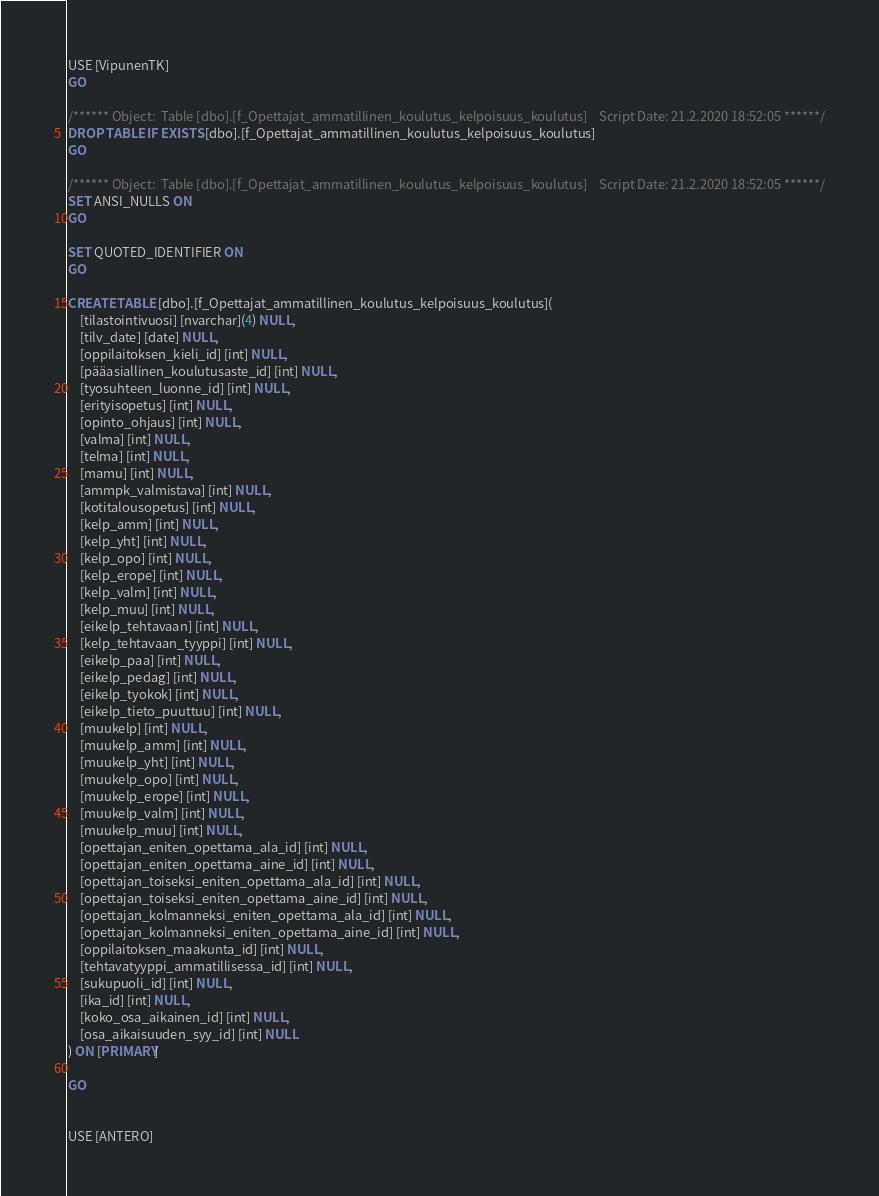Convert code to text. <code><loc_0><loc_0><loc_500><loc_500><_SQL_>USE [VipunenTK]
GO

/****** Object:  Table [dbo].[f_Opettajat_ammatillinen_koulutus_kelpoisuus_koulutus]    Script Date: 21.2.2020 18:52:05 ******/
DROP TABLE IF EXISTS [dbo].[f_Opettajat_ammatillinen_koulutus_kelpoisuus_koulutus]
GO

/****** Object:  Table [dbo].[f_Opettajat_ammatillinen_koulutus_kelpoisuus_koulutus]    Script Date: 21.2.2020 18:52:05 ******/
SET ANSI_NULLS ON
GO

SET QUOTED_IDENTIFIER ON
GO

CREATE TABLE [dbo].[f_Opettajat_ammatillinen_koulutus_kelpoisuus_koulutus](
	[tilastointivuosi] [nvarchar](4) NULL,
	[tilv_date] [date] NULL,
	[oppilaitoksen_kieli_id] [int] NULL,
	[pääasiallinen_koulutusaste_id] [int] NULL,
	[tyosuhteen_luonne_id] [int] NULL,
	[erityisopetus] [int] NULL,
	[opinto_ohjaus] [int] NULL,
	[valma] [int] NULL,
	[telma] [int] NULL,
	[mamu] [int] NULL,
	[ammpk_valmistava] [int] NULL,
	[kotitalousopetus] [int] NULL,
	[kelp_amm] [int] NULL,
	[kelp_yht] [int] NULL,
	[kelp_opo] [int] NULL,
	[kelp_erope] [int] NULL,
	[kelp_valm] [int] NULL,
	[kelp_muu] [int] NULL,
	[eikelp_tehtavaan] [int] NULL,
	[kelp_tehtavaan_tyyppi] [int] NULL,
	[eikelp_paa] [int] NULL,
	[eikelp_pedag] [int] NULL,
	[eikelp_tyokok] [int] NULL,
	[eikelp_tieto_puuttuu] [int] NULL,
	[muukelp] [int] NULL,
	[muukelp_amm] [int] NULL,
	[muukelp_yht] [int] NULL,
	[muukelp_opo] [int] NULL,
	[muukelp_erope] [int] NULL,
	[muukelp_valm] [int] NULL,
	[muukelp_muu] [int] NULL,
	[opettajan_eniten_opettama_ala_id] [int] NULL,
	[opettajan_eniten_opettama_aine_id] [int] NULL,
	[opettajan_toiseksi_eniten_opettama_ala_id] [int] NULL,
	[opettajan_toiseksi_eniten_opettama_aine_id] [int] NULL,
	[opettajan_kolmanneksi_eniten_opettama_ala_id] [int] NULL,
	[opettajan_kolmanneksi_eniten_opettama_aine_id] [int] NULL,
	[oppilaitoksen_maakunta_id] [int] NULL,
	[tehtavatyyppi_ammatillisessa_id] [int] NULL,
	[sukupuoli_id] [int] NULL,
	[ika_id] [int] NULL,
	[koko_osa_aikainen_id] [int] NULL,
	[osa_aikaisuuden_syy_id] [int] NULL
) ON [PRIMARY]

GO


USE [ANTERO]</code> 